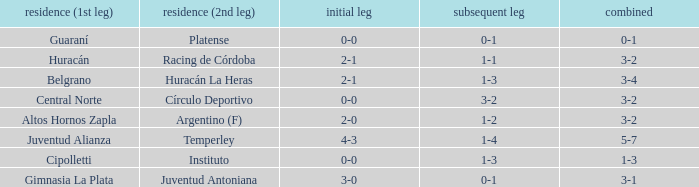What was the score of the 2nd leg when the Belgrano played the first leg at home with a score of 2-1? 1-3. 